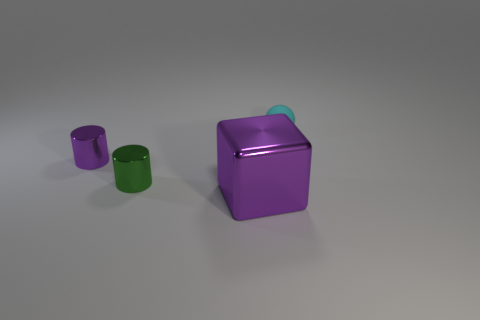Subtract 1 blocks. How many blocks are left? 0 Subtract all purple cylinders. How many cylinders are left? 1 Subtract all cyan cylinders. How many red cubes are left? 0 Add 2 large metallic cubes. How many large metallic cubes exist? 3 Add 1 tiny cyan matte spheres. How many objects exist? 5 Subtract 0 brown balls. How many objects are left? 4 Subtract all balls. How many objects are left? 3 Subtract all gray cylinders. Subtract all brown spheres. How many cylinders are left? 2 Subtract all purple cylinders. Subtract all small cylinders. How many objects are left? 1 Add 1 shiny cylinders. How many shiny cylinders are left? 3 